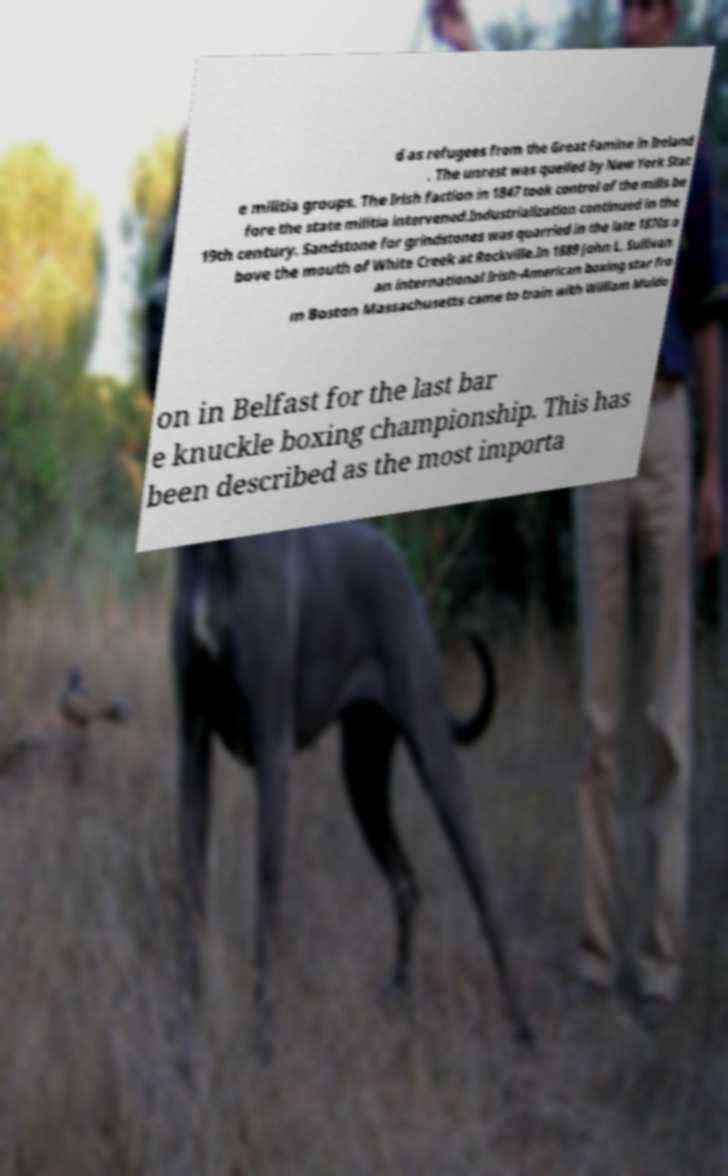What messages or text are displayed in this image? I need them in a readable, typed format. d as refugees from the Great Famine in Ireland . The unrest was quelled by New York Stat e militia groups. The Irish faction in 1847 took control of the mills be fore the state militia intervened.Industrialization continued in the 19th century. Sandstone for grindstones was quarried in the late 1870s a bove the mouth of White Creek at Rockville.In 1889 John L. Sullivan an international Irish-American boxing star fro m Boston Massachusetts came to train with William Muldo on in Belfast for the last bar e knuckle boxing championship. This has been described as the most importa 